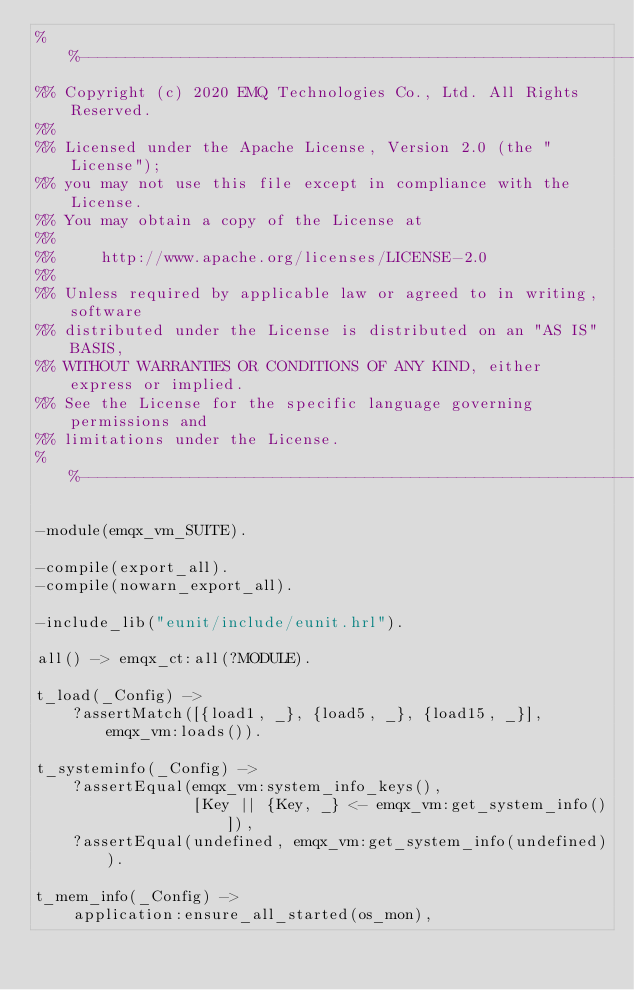<code> <loc_0><loc_0><loc_500><loc_500><_Erlang_>%%--------------------------------------------------------------------
%% Copyright (c) 2020 EMQ Technologies Co., Ltd. All Rights Reserved.
%%
%% Licensed under the Apache License, Version 2.0 (the "License");
%% you may not use this file except in compliance with the License.
%% You may obtain a copy of the License at
%%
%%     http://www.apache.org/licenses/LICENSE-2.0
%%
%% Unless required by applicable law or agreed to in writing, software
%% distributed under the License is distributed on an "AS IS" BASIS,
%% WITHOUT WARRANTIES OR CONDITIONS OF ANY KIND, either express or implied.
%% See the License for the specific language governing permissions and
%% limitations under the License.
%%--------------------------------------------------------------------

-module(emqx_vm_SUITE).

-compile(export_all).
-compile(nowarn_export_all).

-include_lib("eunit/include/eunit.hrl").

all() -> emqx_ct:all(?MODULE).

t_load(_Config) ->
    ?assertMatch([{load1, _}, {load5, _}, {load15, _}], emqx_vm:loads()).

t_systeminfo(_Config) ->
    ?assertEqual(emqx_vm:system_info_keys(),
                 [Key || {Key, _} <- emqx_vm:get_system_info()]),
    ?assertEqual(undefined, emqx_vm:get_system_info(undefined)).

t_mem_info(_Config) ->
    application:ensure_all_started(os_mon),</code> 